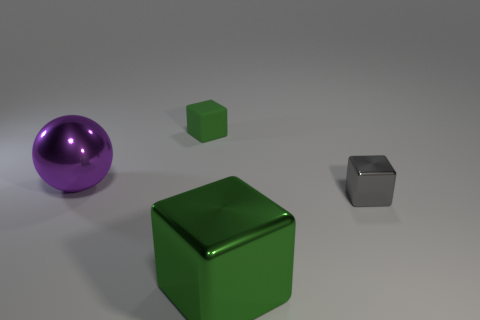Add 3 small green matte things. How many objects exist? 7 Subtract all blocks. How many objects are left? 1 Add 1 cubes. How many cubes are left? 4 Add 2 tiny green objects. How many tiny green objects exist? 3 Subtract 0 yellow cylinders. How many objects are left? 4 Subtract all tiny gray metal things. Subtract all green matte cubes. How many objects are left? 2 